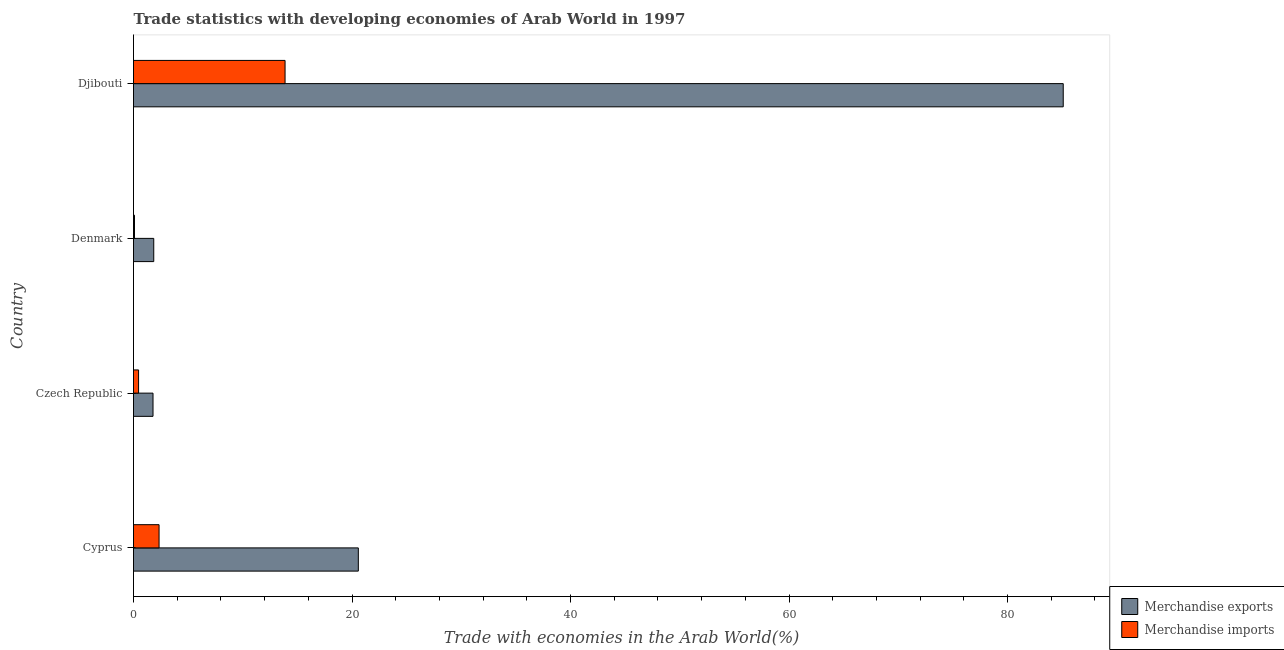How many groups of bars are there?
Your answer should be compact. 4. Are the number of bars per tick equal to the number of legend labels?
Ensure brevity in your answer.  Yes. How many bars are there on the 2nd tick from the top?
Ensure brevity in your answer.  2. How many bars are there on the 2nd tick from the bottom?
Make the answer very short. 2. What is the label of the 1st group of bars from the top?
Make the answer very short. Djibouti. In how many cases, is the number of bars for a given country not equal to the number of legend labels?
Make the answer very short. 0. What is the merchandise exports in Cyprus?
Keep it short and to the point. 20.58. Across all countries, what is the maximum merchandise imports?
Provide a short and direct response. 13.87. Across all countries, what is the minimum merchandise exports?
Your response must be concise. 1.79. In which country was the merchandise imports maximum?
Ensure brevity in your answer.  Djibouti. In which country was the merchandise imports minimum?
Provide a short and direct response. Denmark. What is the total merchandise imports in the graph?
Offer a very short reply. 16.77. What is the difference between the merchandise imports in Denmark and that in Djibouti?
Offer a very short reply. -13.78. What is the difference between the merchandise exports in Czech Republic and the merchandise imports in Denmark?
Your response must be concise. 1.69. What is the average merchandise imports per country?
Provide a short and direct response. 4.19. What is the difference between the merchandise exports and merchandise imports in Czech Republic?
Your answer should be very brief. 1.32. In how many countries, is the merchandise imports greater than 8 %?
Your response must be concise. 1. What is the ratio of the merchandise exports in Cyprus to that in Denmark?
Ensure brevity in your answer.  11.11. Is the merchandise exports in Cyprus less than that in Denmark?
Your answer should be very brief. No. Is the difference between the merchandise exports in Czech Republic and Djibouti greater than the difference between the merchandise imports in Czech Republic and Djibouti?
Keep it short and to the point. No. What is the difference between the highest and the second highest merchandise imports?
Your response must be concise. 11.53. What is the difference between the highest and the lowest merchandise exports?
Your response must be concise. 83.31. In how many countries, is the merchandise imports greater than the average merchandise imports taken over all countries?
Keep it short and to the point. 1. What does the 2nd bar from the bottom in Denmark represents?
Offer a terse response. Merchandise imports. How many bars are there?
Your answer should be compact. 8. Are the values on the major ticks of X-axis written in scientific E-notation?
Offer a terse response. No. Where does the legend appear in the graph?
Provide a short and direct response. Bottom right. How many legend labels are there?
Your response must be concise. 2. How are the legend labels stacked?
Offer a terse response. Vertical. What is the title of the graph?
Your answer should be very brief. Trade statistics with developing economies of Arab World in 1997. What is the label or title of the X-axis?
Your answer should be compact. Trade with economies in the Arab World(%). What is the Trade with economies in the Arab World(%) of Merchandise exports in Cyprus?
Ensure brevity in your answer.  20.58. What is the Trade with economies in the Arab World(%) of Merchandise imports in Cyprus?
Your response must be concise. 2.34. What is the Trade with economies in the Arab World(%) in Merchandise exports in Czech Republic?
Ensure brevity in your answer.  1.79. What is the Trade with economies in the Arab World(%) in Merchandise imports in Czech Republic?
Keep it short and to the point. 0.46. What is the Trade with economies in the Arab World(%) in Merchandise exports in Denmark?
Give a very brief answer. 1.85. What is the Trade with economies in the Arab World(%) of Merchandise imports in Denmark?
Offer a very short reply. 0.09. What is the Trade with economies in the Arab World(%) of Merchandise exports in Djibouti?
Offer a terse response. 85.1. What is the Trade with economies in the Arab World(%) in Merchandise imports in Djibouti?
Your answer should be compact. 13.87. Across all countries, what is the maximum Trade with economies in the Arab World(%) in Merchandise exports?
Provide a succinct answer. 85.1. Across all countries, what is the maximum Trade with economies in the Arab World(%) in Merchandise imports?
Ensure brevity in your answer.  13.87. Across all countries, what is the minimum Trade with economies in the Arab World(%) in Merchandise exports?
Your answer should be very brief. 1.79. Across all countries, what is the minimum Trade with economies in the Arab World(%) of Merchandise imports?
Your answer should be very brief. 0.09. What is the total Trade with economies in the Arab World(%) of Merchandise exports in the graph?
Give a very brief answer. 109.31. What is the total Trade with economies in the Arab World(%) of Merchandise imports in the graph?
Offer a terse response. 16.77. What is the difference between the Trade with economies in the Arab World(%) in Merchandise exports in Cyprus and that in Czech Republic?
Your response must be concise. 18.79. What is the difference between the Trade with economies in the Arab World(%) in Merchandise imports in Cyprus and that in Czech Republic?
Offer a terse response. 1.88. What is the difference between the Trade with economies in the Arab World(%) of Merchandise exports in Cyprus and that in Denmark?
Ensure brevity in your answer.  18.72. What is the difference between the Trade with economies in the Arab World(%) of Merchandise imports in Cyprus and that in Denmark?
Make the answer very short. 2.25. What is the difference between the Trade with economies in the Arab World(%) of Merchandise exports in Cyprus and that in Djibouti?
Offer a terse response. -64.52. What is the difference between the Trade with economies in the Arab World(%) in Merchandise imports in Cyprus and that in Djibouti?
Your answer should be compact. -11.53. What is the difference between the Trade with economies in the Arab World(%) of Merchandise exports in Czech Republic and that in Denmark?
Offer a very short reply. -0.07. What is the difference between the Trade with economies in the Arab World(%) of Merchandise imports in Czech Republic and that in Denmark?
Provide a succinct answer. 0.37. What is the difference between the Trade with economies in the Arab World(%) of Merchandise exports in Czech Republic and that in Djibouti?
Make the answer very short. -83.31. What is the difference between the Trade with economies in the Arab World(%) in Merchandise imports in Czech Republic and that in Djibouti?
Keep it short and to the point. -13.41. What is the difference between the Trade with economies in the Arab World(%) in Merchandise exports in Denmark and that in Djibouti?
Your response must be concise. -83.24. What is the difference between the Trade with economies in the Arab World(%) in Merchandise imports in Denmark and that in Djibouti?
Offer a terse response. -13.78. What is the difference between the Trade with economies in the Arab World(%) of Merchandise exports in Cyprus and the Trade with economies in the Arab World(%) of Merchandise imports in Czech Republic?
Ensure brevity in your answer.  20.11. What is the difference between the Trade with economies in the Arab World(%) of Merchandise exports in Cyprus and the Trade with economies in the Arab World(%) of Merchandise imports in Denmark?
Keep it short and to the point. 20.49. What is the difference between the Trade with economies in the Arab World(%) in Merchandise exports in Cyprus and the Trade with economies in the Arab World(%) in Merchandise imports in Djibouti?
Make the answer very short. 6.71. What is the difference between the Trade with economies in the Arab World(%) of Merchandise exports in Czech Republic and the Trade with economies in the Arab World(%) of Merchandise imports in Denmark?
Give a very brief answer. 1.69. What is the difference between the Trade with economies in the Arab World(%) in Merchandise exports in Czech Republic and the Trade with economies in the Arab World(%) in Merchandise imports in Djibouti?
Give a very brief answer. -12.09. What is the difference between the Trade with economies in the Arab World(%) in Merchandise exports in Denmark and the Trade with economies in the Arab World(%) in Merchandise imports in Djibouti?
Provide a succinct answer. -12.02. What is the average Trade with economies in the Arab World(%) of Merchandise exports per country?
Keep it short and to the point. 27.33. What is the average Trade with economies in the Arab World(%) in Merchandise imports per country?
Your answer should be compact. 4.19. What is the difference between the Trade with economies in the Arab World(%) of Merchandise exports and Trade with economies in the Arab World(%) of Merchandise imports in Cyprus?
Offer a very short reply. 18.24. What is the difference between the Trade with economies in the Arab World(%) of Merchandise exports and Trade with economies in the Arab World(%) of Merchandise imports in Czech Republic?
Your answer should be very brief. 1.32. What is the difference between the Trade with economies in the Arab World(%) in Merchandise exports and Trade with economies in the Arab World(%) in Merchandise imports in Denmark?
Keep it short and to the point. 1.76. What is the difference between the Trade with economies in the Arab World(%) of Merchandise exports and Trade with economies in the Arab World(%) of Merchandise imports in Djibouti?
Ensure brevity in your answer.  71.22. What is the ratio of the Trade with economies in the Arab World(%) of Merchandise exports in Cyprus to that in Czech Republic?
Provide a succinct answer. 11.53. What is the ratio of the Trade with economies in the Arab World(%) in Merchandise imports in Cyprus to that in Czech Republic?
Make the answer very short. 5.05. What is the ratio of the Trade with economies in the Arab World(%) in Merchandise exports in Cyprus to that in Denmark?
Offer a terse response. 11.11. What is the ratio of the Trade with economies in the Arab World(%) in Merchandise imports in Cyprus to that in Denmark?
Your answer should be very brief. 25.55. What is the ratio of the Trade with economies in the Arab World(%) of Merchandise exports in Cyprus to that in Djibouti?
Ensure brevity in your answer.  0.24. What is the ratio of the Trade with economies in the Arab World(%) in Merchandise imports in Cyprus to that in Djibouti?
Provide a short and direct response. 0.17. What is the ratio of the Trade with economies in the Arab World(%) in Merchandise exports in Czech Republic to that in Denmark?
Offer a very short reply. 0.96. What is the ratio of the Trade with economies in the Arab World(%) of Merchandise imports in Czech Republic to that in Denmark?
Offer a terse response. 5.06. What is the ratio of the Trade with economies in the Arab World(%) of Merchandise exports in Czech Republic to that in Djibouti?
Your response must be concise. 0.02. What is the ratio of the Trade with economies in the Arab World(%) of Merchandise imports in Czech Republic to that in Djibouti?
Give a very brief answer. 0.03. What is the ratio of the Trade with economies in the Arab World(%) of Merchandise exports in Denmark to that in Djibouti?
Offer a very short reply. 0.02. What is the ratio of the Trade with economies in the Arab World(%) of Merchandise imports in Denmark to that in Djibouti?
Your answer should be compact. 0.01. What is the difference between the highest and the second highest Trade with economies in the Arab World(%) in Merchandise exports?
Your response must be concise. 64.52. What is the difference between the highest and the second highest Trade with economies in the Arab World(%) of Merchandise imports?
Your answer should be compact. 11.53. What is the difference between the highest and the lowest Trade with economies in the Arab World(%) in Merchandise exports?
Ensure brevity in your answer.  83.31. What is the difference between the highest and the lowest Trade with economies in the Arab World(%) in Merchandise imports?
Ensure brevity in your answer.  13.78. 